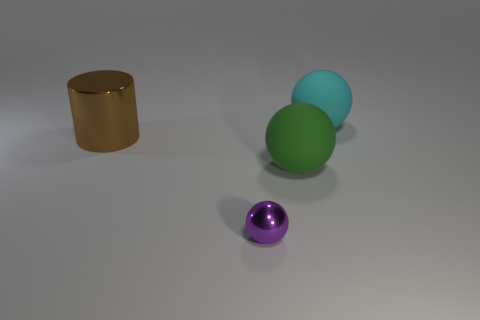Subtract all large spheres. How many spheres are left? 1 Add 1 small gray shiny cubes. How many objects exist? 5 Subtract all spheres. How many objects are left? 1 Subtract all brown spheres. Subtract all brown cylinders. How many spheres are left? 3 Add 3 large things. How many large things exist? 6 Subtract 0 green cylinders. How many objects are left? 4 Subtract all blue metal cubes. Subtract all big cylinders. How many objects are left? 3 Add 3 rubber objects. How many rubber objects are left? 5 